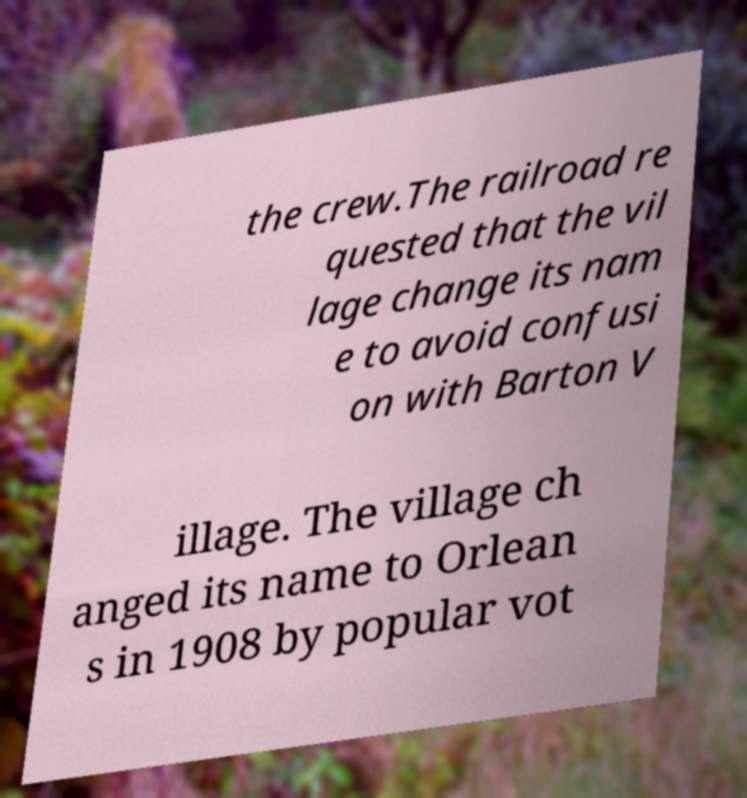Please identify and transcribe the text found in this image. the crew.The railroad re quested that the vil lage change its nam e to avoid confusi on with Barton V illage. The village ch anged its name to Orlean s in 1908 by popular vot 